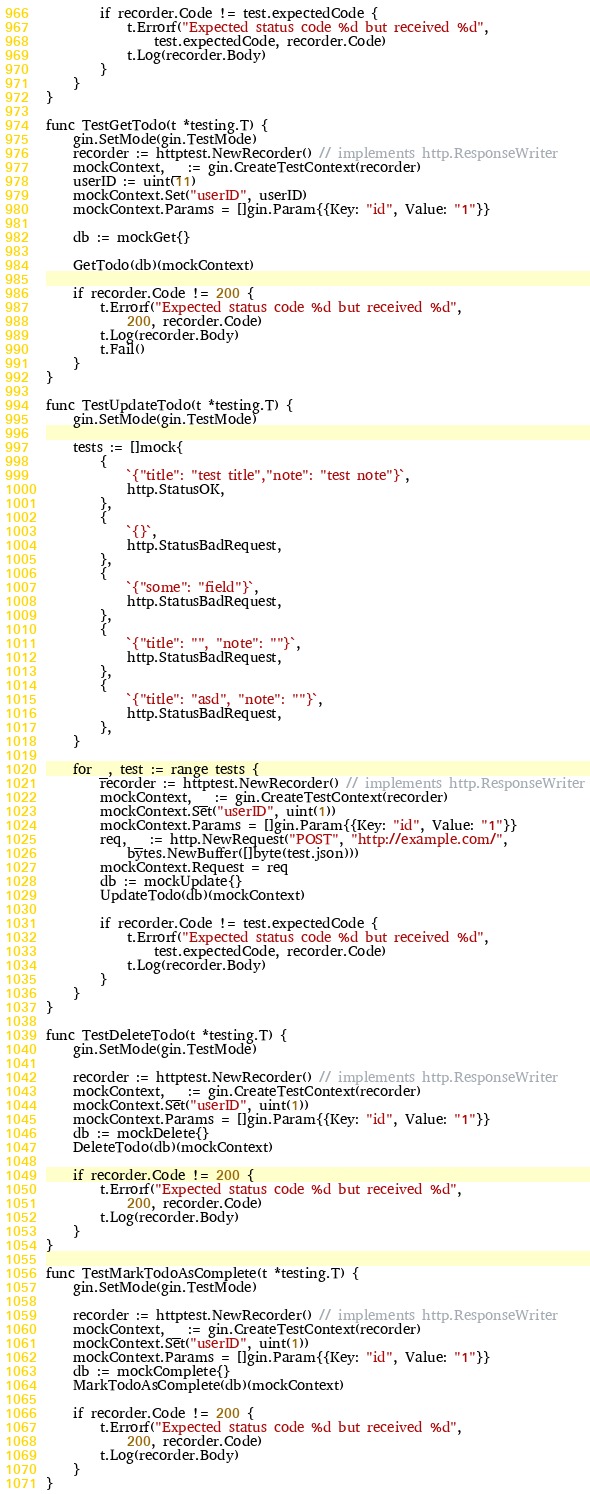<code> <loc_0><loc_0><loc_500><loc_500><_Go_>		if recorder.Code != test.expectedCode {
			t.Errorf("Expected status code %d but received %d",
				test.expectedCode, recorder.Code)
			t.Log(recorder.Body)
		}
	}
}

func TestGetTodo(t *testing.T) {
	gin.SetMode(gin.TestMode)
	recorder := httptest.NewRecorder() // implements http.ResponseWriter
	mockContext, _ := gin.CreateTestContext(recorder)
	userID := uint(11)
	mockContext.Set("userID", userID)
	mockContext.Params = []gin.Param{{Key: "id", Value: "1"}}

	db := mockGet{}

	GetTodo(db)(mockContext)

	if recorder.Code != 200 {
		t.Errorf("Expected status code %d but received %d",
			200, recorder.Code)
		t.Log(recorder.Body)
		t.Fail()
	}
}

func TestUpdateTodo(t *testing.T) {
	gin.SetMode(gin.TestMode)

	tests := []mock{
		{
			`{"title": "test title","note": "test note"}`,
			http.StatusOK,
		},
		{
			`{}`,
			http.StatusBadRequest,
		},
		{
			`{"some": "field"}`,
			http.StatusBadRequest,
		},
		{
			`{"title": "", "note": ""}`,
			http.StatusBadRequest,
		},
		{
			`{"title": "asd", "note": ""}`,
			http.StatusBadRequest,
		},
	}

	for _, test := range tests {
		recorder := httptest.NewRecorder() // implements http.ResponseWriter
		mockContext, _ := gin.CreateTestContext(recorder)
		mockContext.Set("userID", uint(1))
		mockContext.Params = []gin.Param{{Key: "id", Value: "1"}}
		req, _ := http.NewRequest("POST", "http://example.com/",
			bytes.NewBuffer([]byte(test.json)))
		mockContext.Request = req
		db := mockUpdate{}
		UpdateTodo(db)(mockContext)

		if recorder.Code != test.expectedCode {
			t.Errorf("Expected status code %d but received %d",
				test.expectedCode, recorder.Code)
			t.Log(recorder.Body)
		}
	}
}

func TestDeleteTodo(t *testing.T) {
	gin.SetMode(gin.TestMode)

	recorder := httptest.NewRecorder() // implements http.ResponseWriter
	mockContext, _ := gin.CreateTestContext(recorder)
	mockContext.Set("userID", uint(1))
	mockContext.Params = []gin.Param{{Key: "id", Value: "1"}}
	db := mockDelete{}
	DeleteTodo(db)(mockContext)

	if recorder.Code != 200 {
		t.Errorf("Expected status code %d but received %d",
			200, recorder.Code)
		t.Log(recorder.Body)
	}
}

func TestMarkTodoAsComplete(t *testing.T) {
	gin.SetMode(gin.TestMode)

	recorder := httptest.NewRecorder() // implements http.ResponseWriter
	mockContext, _ := gin.CreateTestContext(recorder)
	mockContext.Set("userID", uint(1))
	mockContext.Params = []gin.Param{{Key: "id", Value: "1"}}
	db := mockComplete{}
	MarkTodoAsComplete(db)(mockContext)

	if recorder.Code != 200 {
		t.Errorf("Expected status code %d but received %d",
			200, recorder.Code)
		t.Log(recorder.Body)
	}
}
</code> 